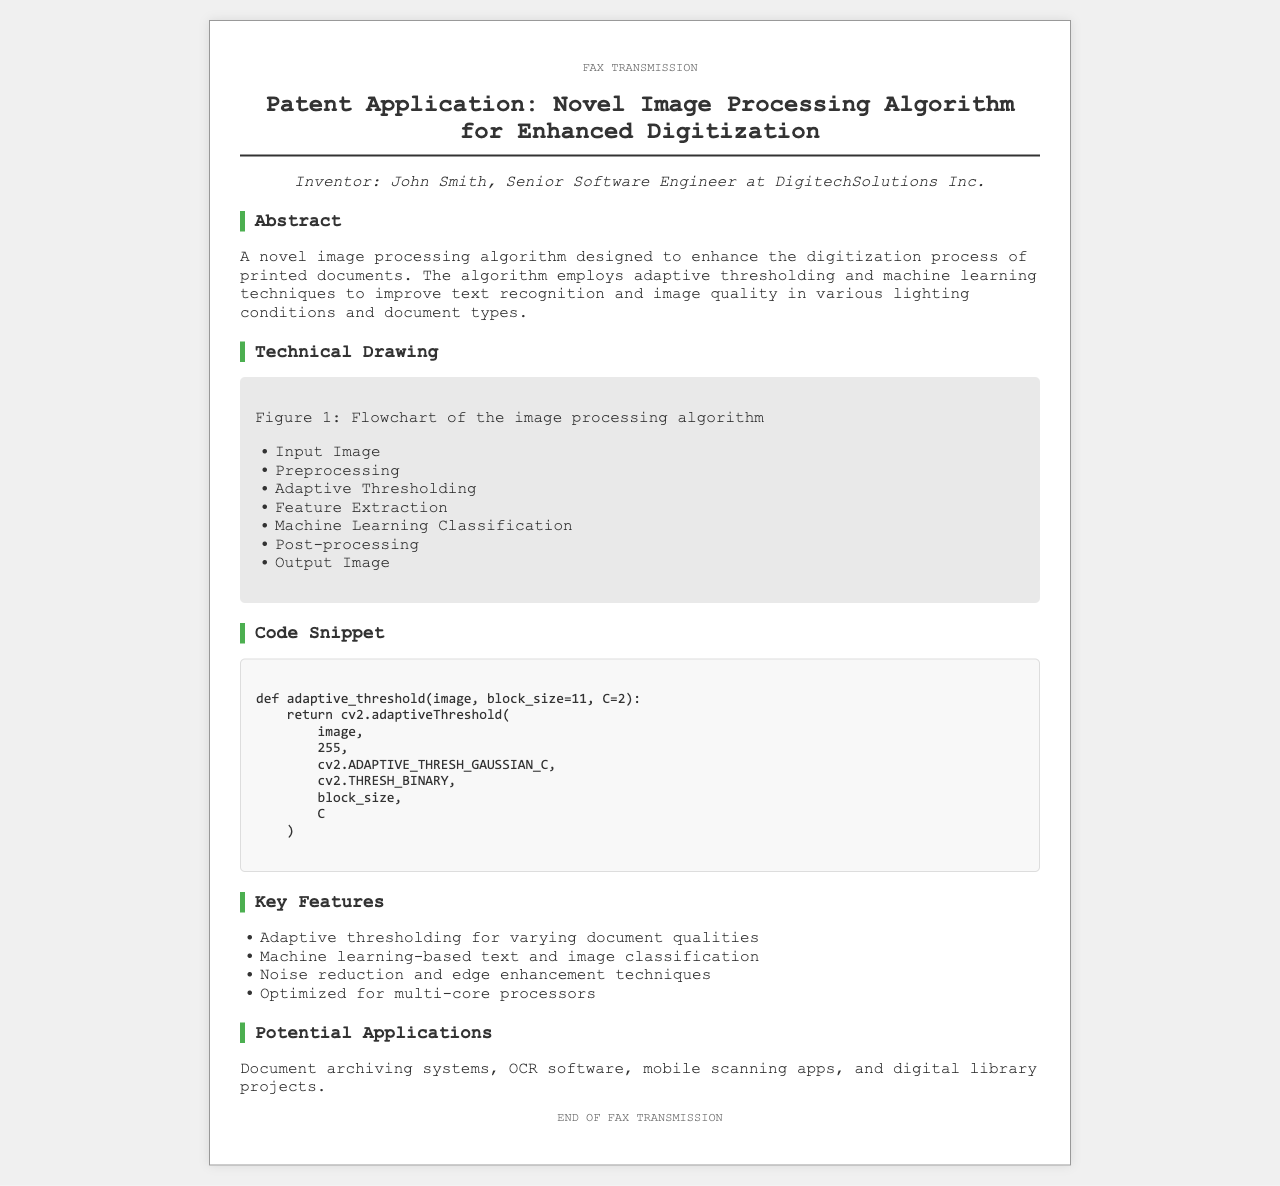What is the title of the patent application? The title of the patent application is stated at the top of the document after the heading, which is "Patent Application: Novel Image Processing Algorithm for Enhanced Digitization".
Answer: Patent Application: Novel Image Processing Algorithm for Enhanced Digitization Who is the inventor of the algorithm? The inventor's name is mentioned under the inventor section of the document, which identifies him as John Smith.
Answer: John Smith What technique does the algorithm employ for improving text recognition? The document highlights that the algorithm employs adaptive thresholding and machine learning techniques to enhance text recognition.
Answer: Adaptive thresholding and machine learning techniques What is the main purpose of the algorithm? The abstract section discusses the purpose of the algorithm, which is to enhance the digitization process of printed documents.
Answer: Enhance the digitization process of printed documents What programming function is shown in the code snippet? The code snippet showcases a function that performs adaptive thresholding on an image, as described in the document.
Answer: Adaptive threshold In which field could this algorithm be applied? The potential applications mentioned in the document include OCR software, indicating a specific field where the algorithm could be utilized.
Answer: OCR software What is the block size parameter in the code snippet? The code snippet indicates that the block size parameter defaults to 11 in the adaptive threshold function.
Answer: 11 What step comes after preprocessing in the algorithm flowchart? The technical drawing lists the steps of the algorithm, showing that the step following preprocessing is adaptive thresholding.
Answer: Adaptive Thresholding 